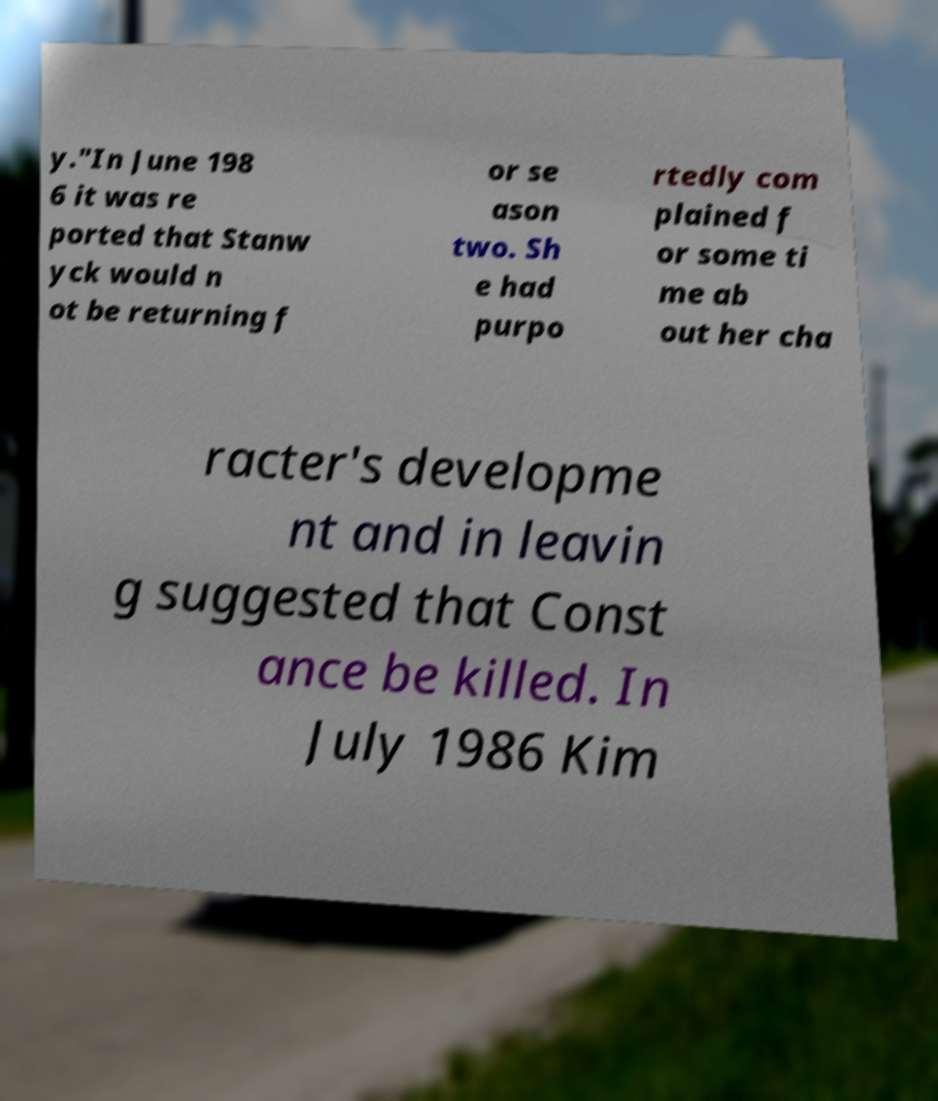For documentation purposes, I need the text within this image transcribed. Could you provide that? y."In June 198 6 it was re ported that Stanw yck would n ot be returning f or se ason two. Sh e had purpo rtedly com plained f or some ti me ab out her cha racter's developme nt and in leavin g suggested that Const ance be killed. In July 1986 Kim 